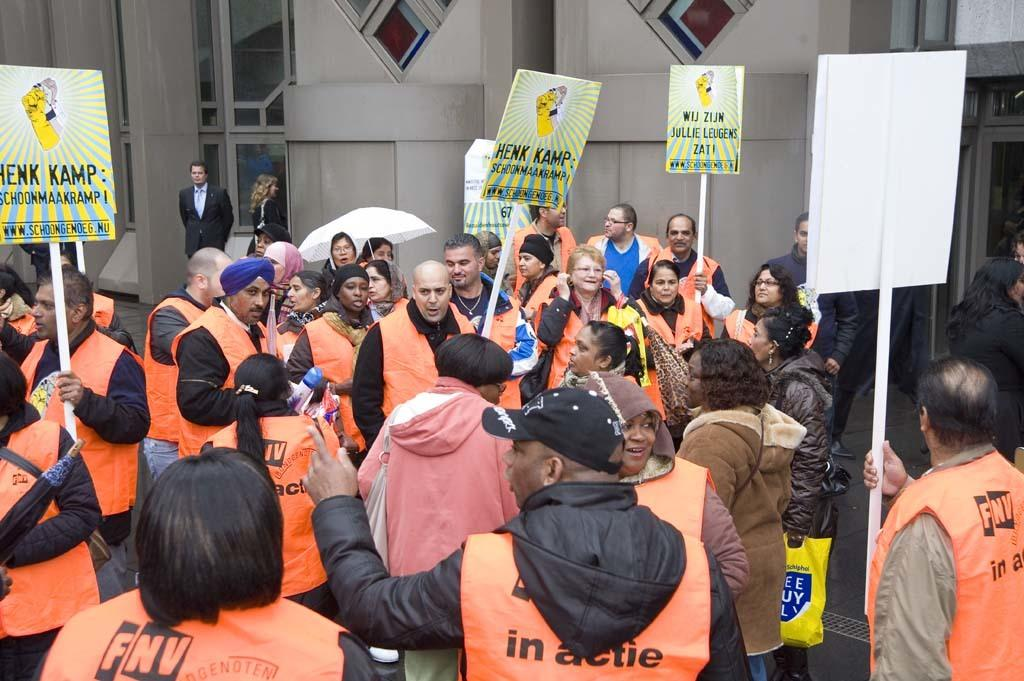<image>
Summarize the visual content of the image. Group of people holding signs including one that says HENK KAMP. 